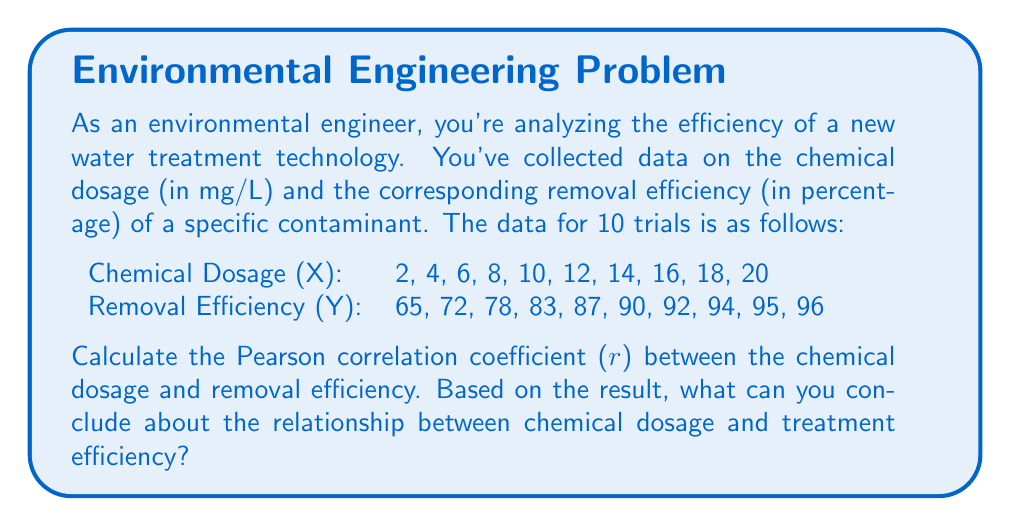What is the answer to this math problem? To calculate the Pearson correlation coefficient (r), we'll use the formula:

$$ r = \frac{n\sum xy - \sum x \sum y}{\sqrt{[n\sum x^2 - (\sum x)^2][n\sum y^2 - (\sum y)^2]}} $$

Where:
n = number of pairs of data
x = chemical dosage
y = removal efficiency

Step 1: Calculate the necessary sums:
$\sum x = 110$
$\sum y = 852$
$\sum xy = 10,580$
$\sum x^2 = 1,540$
$\sum y^2 = 73,218$

Step 2: Substitute these values into the formula:

$$ r = \frac{10(10,580) - (110)(852)}{\sqrt{[10(1,540) - (110)^2][10(73,218) - (852)^2]}} $$

Step 3: Simplify:

$$ r = \frac{105,800 - 93,720}{\sqrt{(15,400 - 12,100)(732,180 - 725,904)}} $$

$$ r = \frac{12,080}{\sqrt{(3,300)(6,276)}} $$

$$ r = \frac{12,080}{\sqrt{20,710,800}} $$

$$ r = \frac{12,080}{4,551.14} $$

$$ r \approx 0.9845 $$

The Pearson correlation coefficient is approximately 0.9845, which indicates a very strong positive correlation between chemical dosage and removal efficiency.

Interpretation:
- The correlation coefficient ranges from -1 to 1.
- A value close to 1 indicates a strong positive correlation.
- In this case, 0.9845 is very close to 1, suggesting a nearly perfect positive linear relationship.

This means that as the chemical dosage increases, the removal efficiency also increases in a highly predictable manner. The strong positive correlation suggests that the chemical dosage is a crucial factor in determining the treatment efficiency for this particular contaminant and technology.
Answer: The Pearson correlation coefficient (r) between chemical dosage and removal efficiency is approximately 0.9845. This indicates a very strong positive correlation, suggesting that increasing the chemical dosage is highly associated with improved removal efficiency in this water treatment process. 